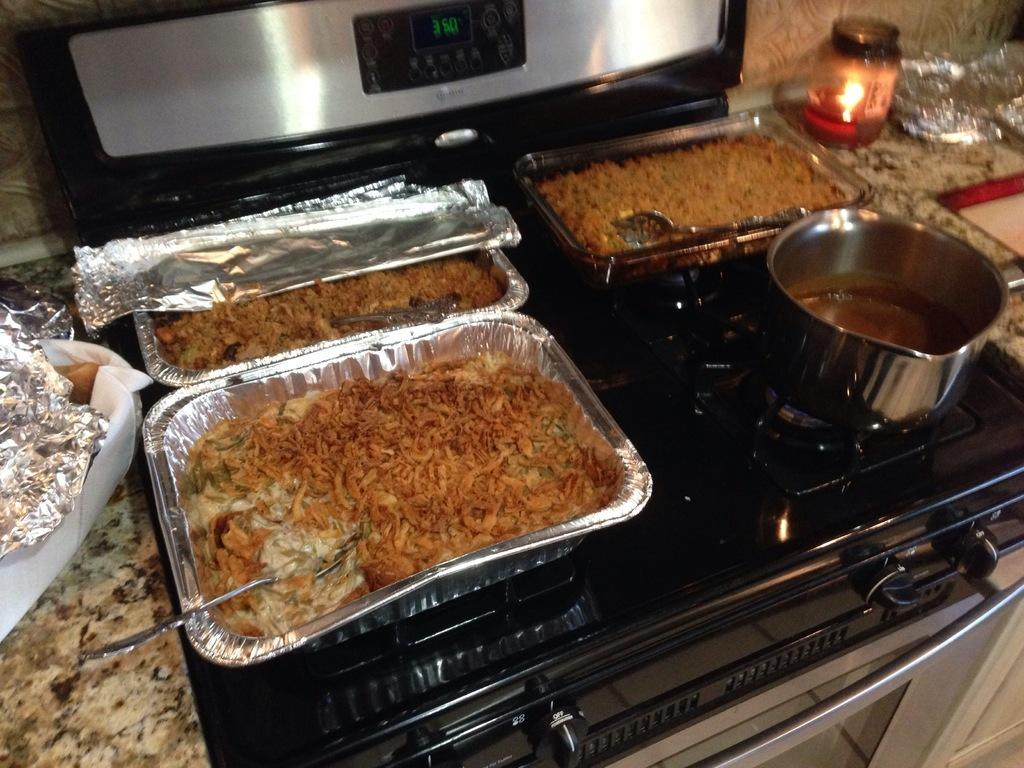What types of items can be seen in the image? There are food items, a candle, spoons, a bowl, and aluminium sheets in the image. What is the purpose of the candle in the image? The purpose of the candle in the image is not clear, but it could be for decoration or lighting. How are the food items being served or stored? The food items are being served or stored in a bowl. What might be used for eating the food items in the image? Spoons can be used for eating the food items in the image. What appliance is visible at the top of the image? There is a microwave oven at the top of the image. What type of underwear is hanging from the microwave oven in the image? There is no underwear present in the image; it only features food items, a candle, spoons, a bowl, aluminium sheets, and a microwave oven. 